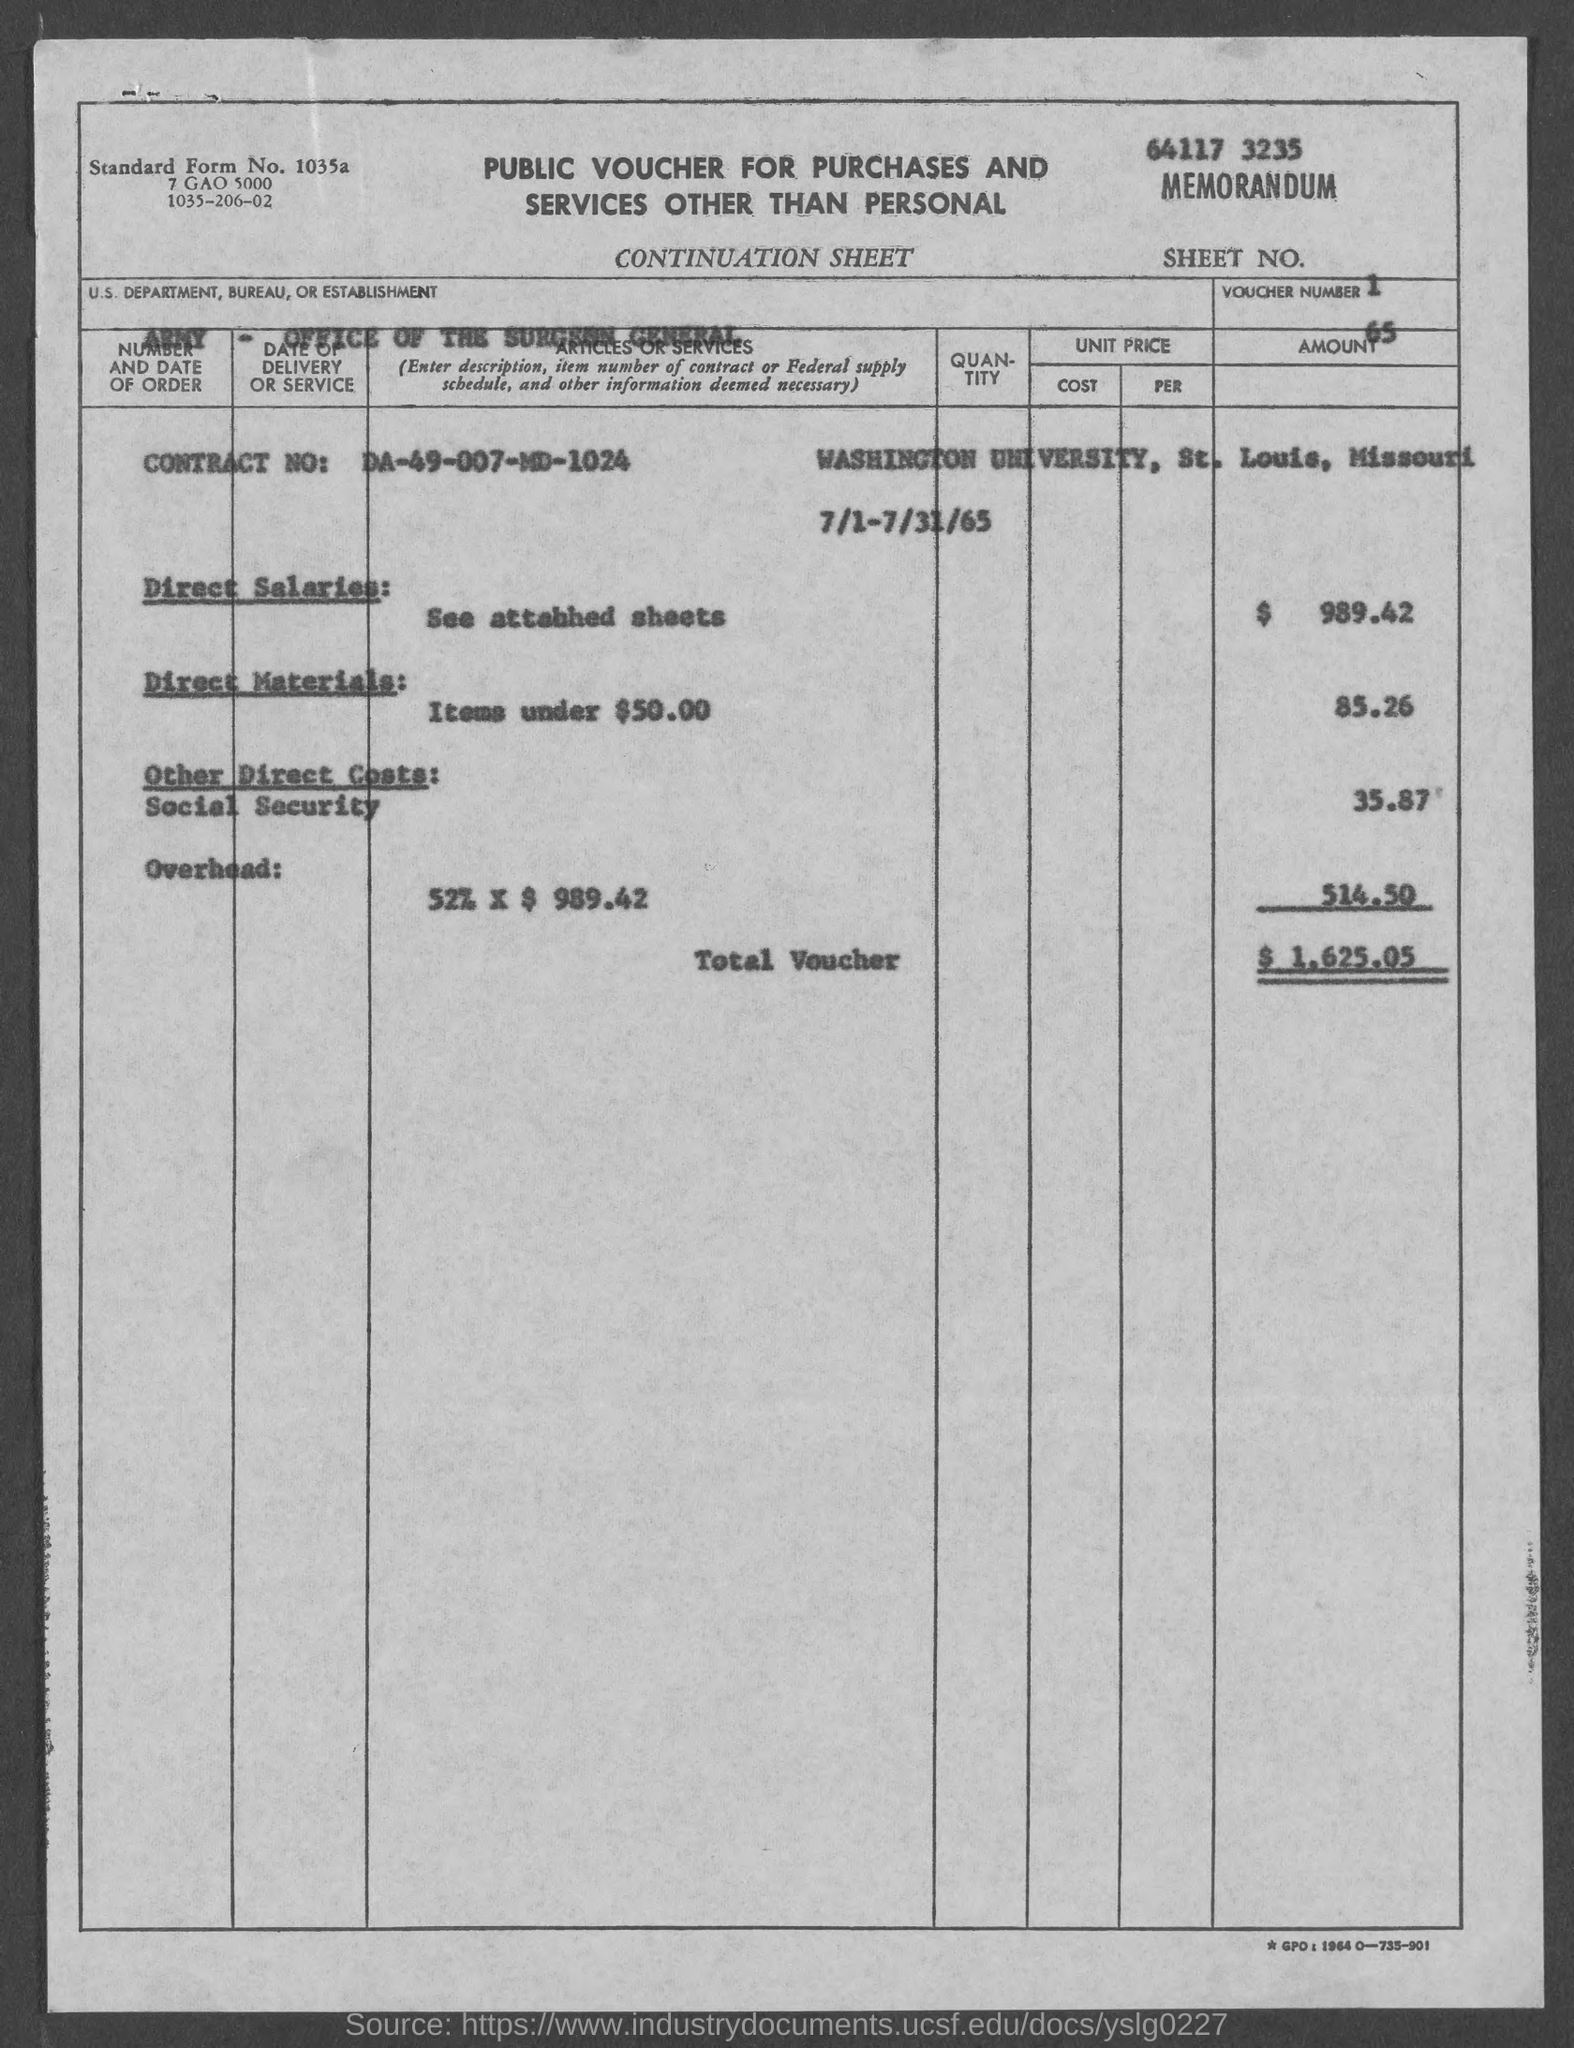What is the Sheet No. mentioned in the voucher?
Your response must be concise. 1. What is the voucher number given in the document?
Your response must be concise. 65. What is the U.S. Department, Bureau, or Establishment given in the voucher?
Provide a short and direct response. ARMY - Office of the Surgeon General. What is the Contract No. given in the voucher?
Ensure brevity in your answer.  DA-49-007-MD-1024. What is the direct salaries cost mentioned in the voucher?
Offer a terse response. 989.42. What is the total amount mentioned in the voucher?
Offer a very short reply. $  1,625.05. What is the Standard Form No. given in the voucher?
Offer a terse response. 1035a. What type of voucher is given here?
Keep it short and to the point. PUBLIC VOUCHER FOR PURCHASES AND SERVICES OTHER THAN PERSONAL. 